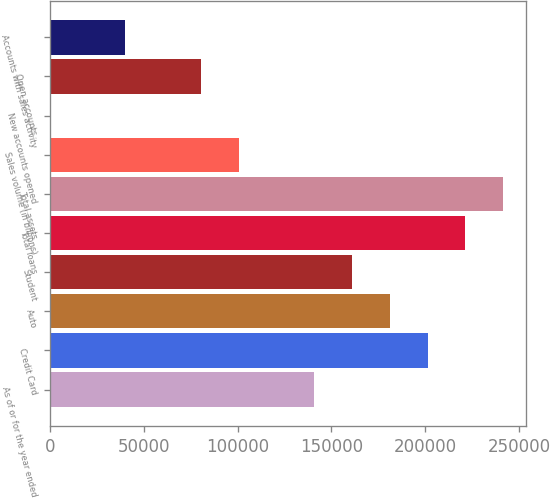Convert chart. <chart><loc_0><loc_0><loc_500><loc_500><bar_chart><fcel>As of or for the year ended<fcel>Credit Card<fcel>Auto<fcel>Student<fcel>Total loans<fcel>Total assets<fcel>Sales volume (in billions)<fcel>New accounts opened<fcel>Open accounts<fcel>Accounts with sales activity<nl><fcel>140816<fcel>201162<fcel>181047<fcel>160931<fcel>221277<fcel>241393<fcel>100585<fcel>8.8<fcel>80470.1<fcel>40239.4<nl></chart> 